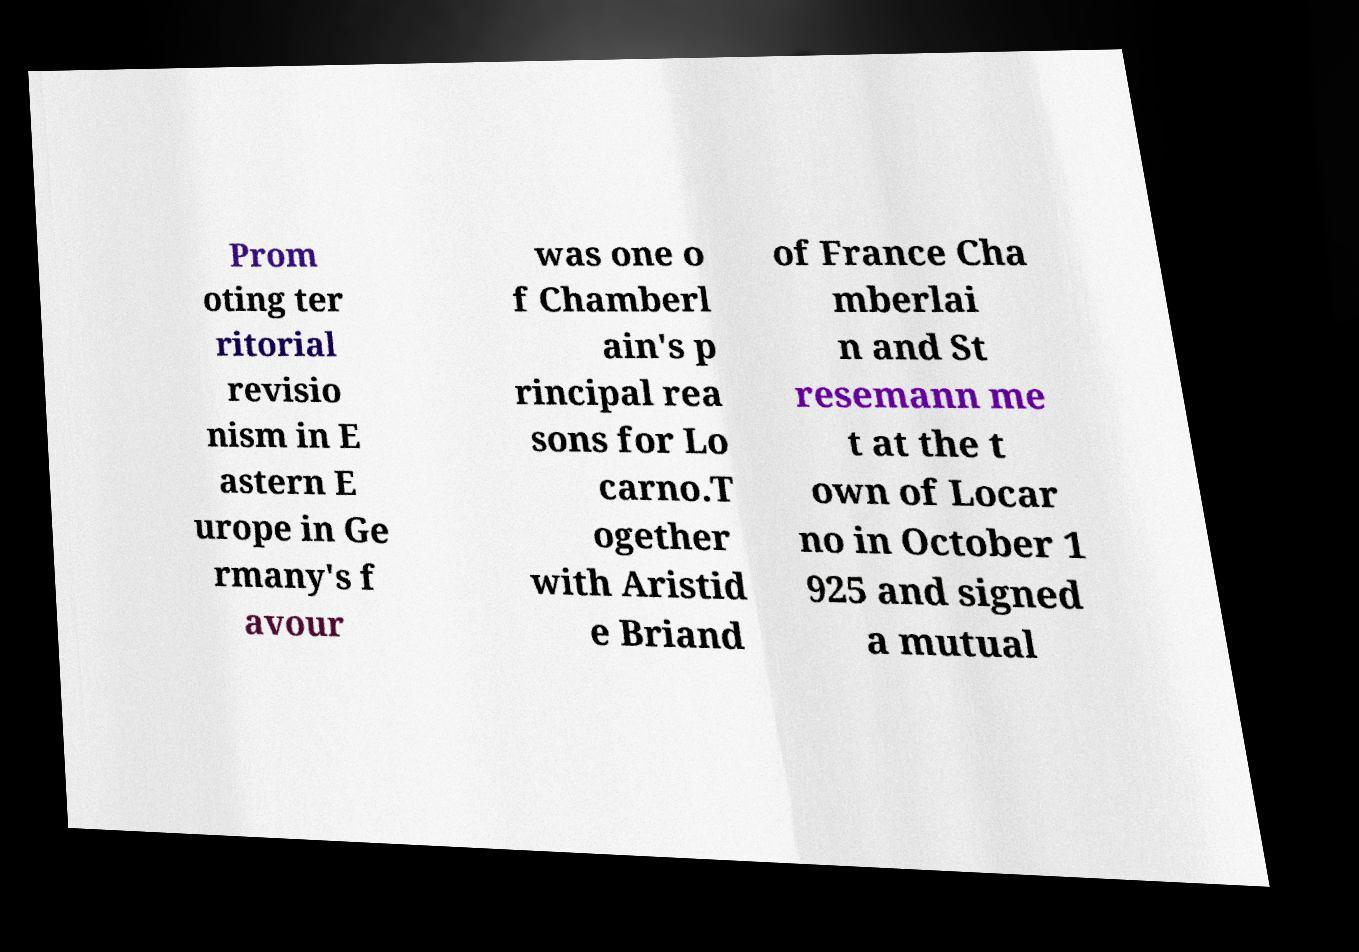Please read and relay the text visible in this image. What does it say? Prom oting ter ritorial revisio nism in E astern E urope in Ge rmany's f avour was one o f Chamberl ain's p rincipal rea sons for Lo carno.T ogether with Aristid e Briand of France Cha mberlai n and St resemann me t at the t own of Locar no in October 1 925 and signed a mutual 